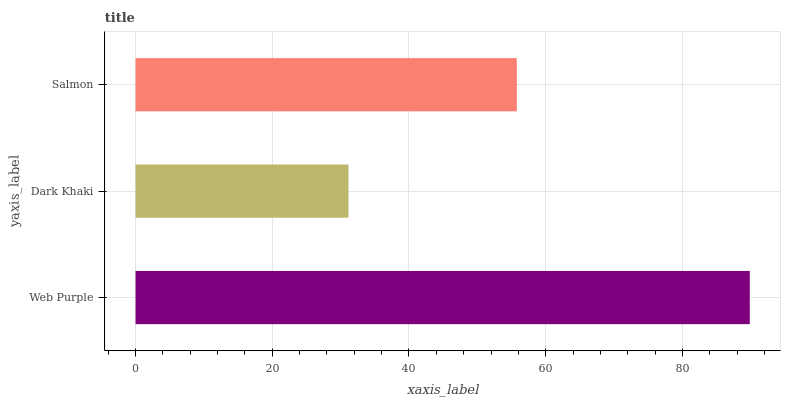Is Dark Khaki the minimum?
Answer yes or no. Yes. Is Web Purple the maximum?
Answer yes or no. Yes. Is Salmon the minimum?
Answer yes or no. No. Is Salmon the maximum?
Answer yes or no. No. Is Salmon greater than Dark Khaki?
Answer yes or no. Yes. Is Dark Khaki less than Salmon?
Answer yes or no. Yes. Is Dark Khaki greater than Salmon?
Answer yes or no. No. Is Salmon less than Dark Khaki?
Answer yes or no. No. Is Salmon the high median?
Answer yes or no. Yes. Is Salmon the low median?
Answer yes or no. Yes. Is Dark Khaki the high median?
Answer yes or no. No. Is Dark Khaki the low median?
Answer yes or no. No. 